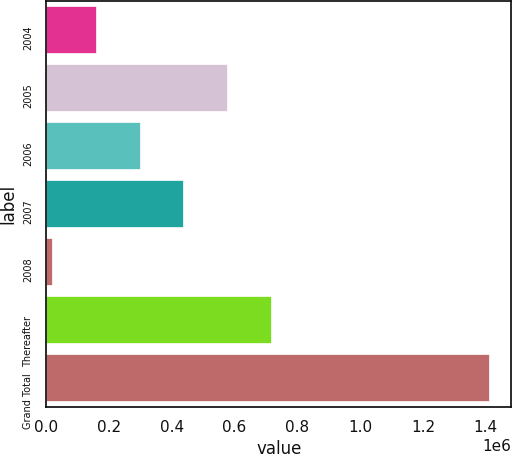<chart> <loc_0><loc_0><loc_500><loc_500><bar_chart><fcel>2004<fcel>2005<fcel>2006<fcel>2007<fcel>2008<fcel>Thereafter<fcel>Grand Total<nl><fcel>158932<fcel>576364<fcel>298076<fcel>437220<fcel>19788<fcel>715508<fcel>1.41123e+06<nl></chart> 